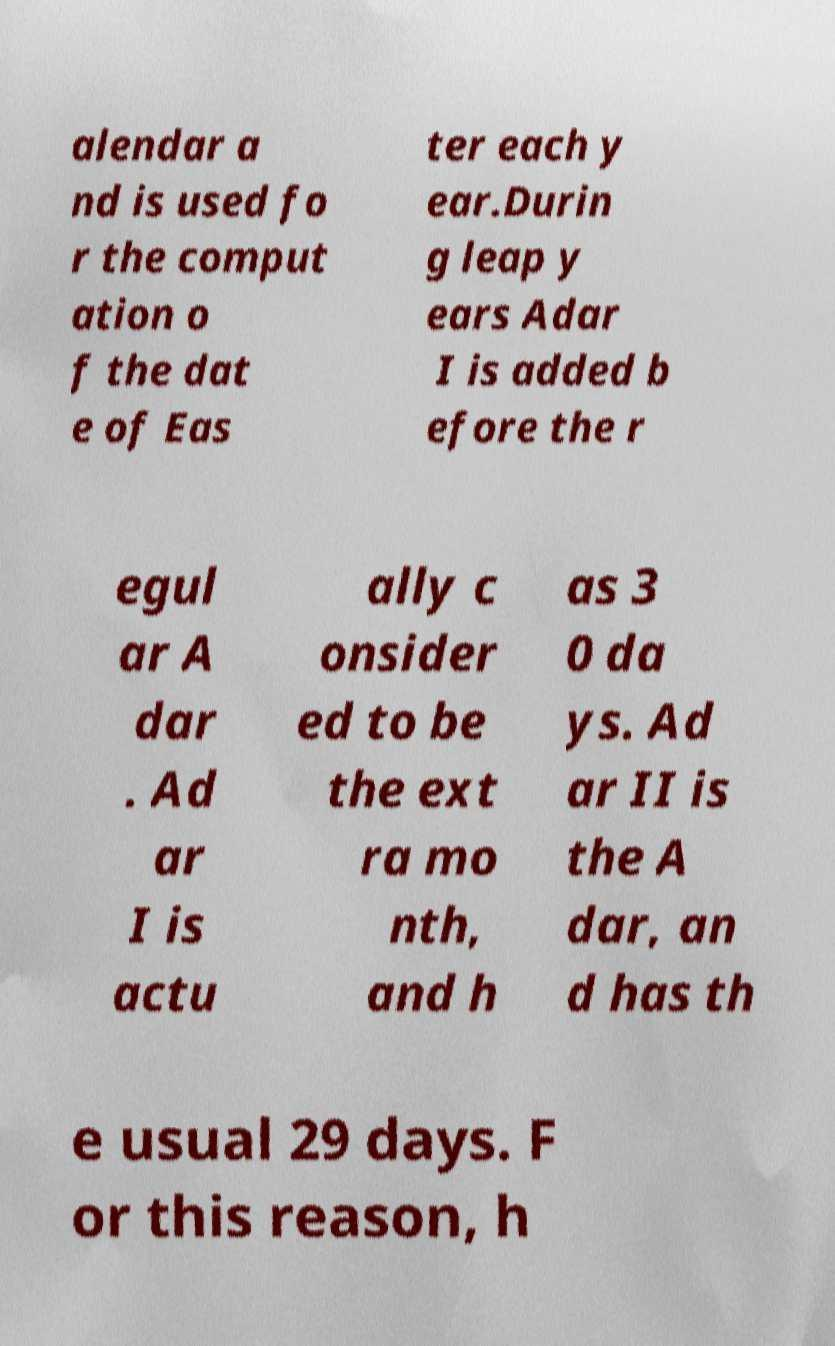Could you extract and type out the text from this image? alendar a nd is used fo r the comput ation o f the dat e of Eas ter each y ear.Durin g leap y ears Adar I is added b efore the r egul ar A dar . Ad ar I is actu ally c onsider ed to be the ext ra mo nth, and h as 3 0 da ys. Ad ar II is the A dar, an d has th e usual 29 days. F or this reason, h 